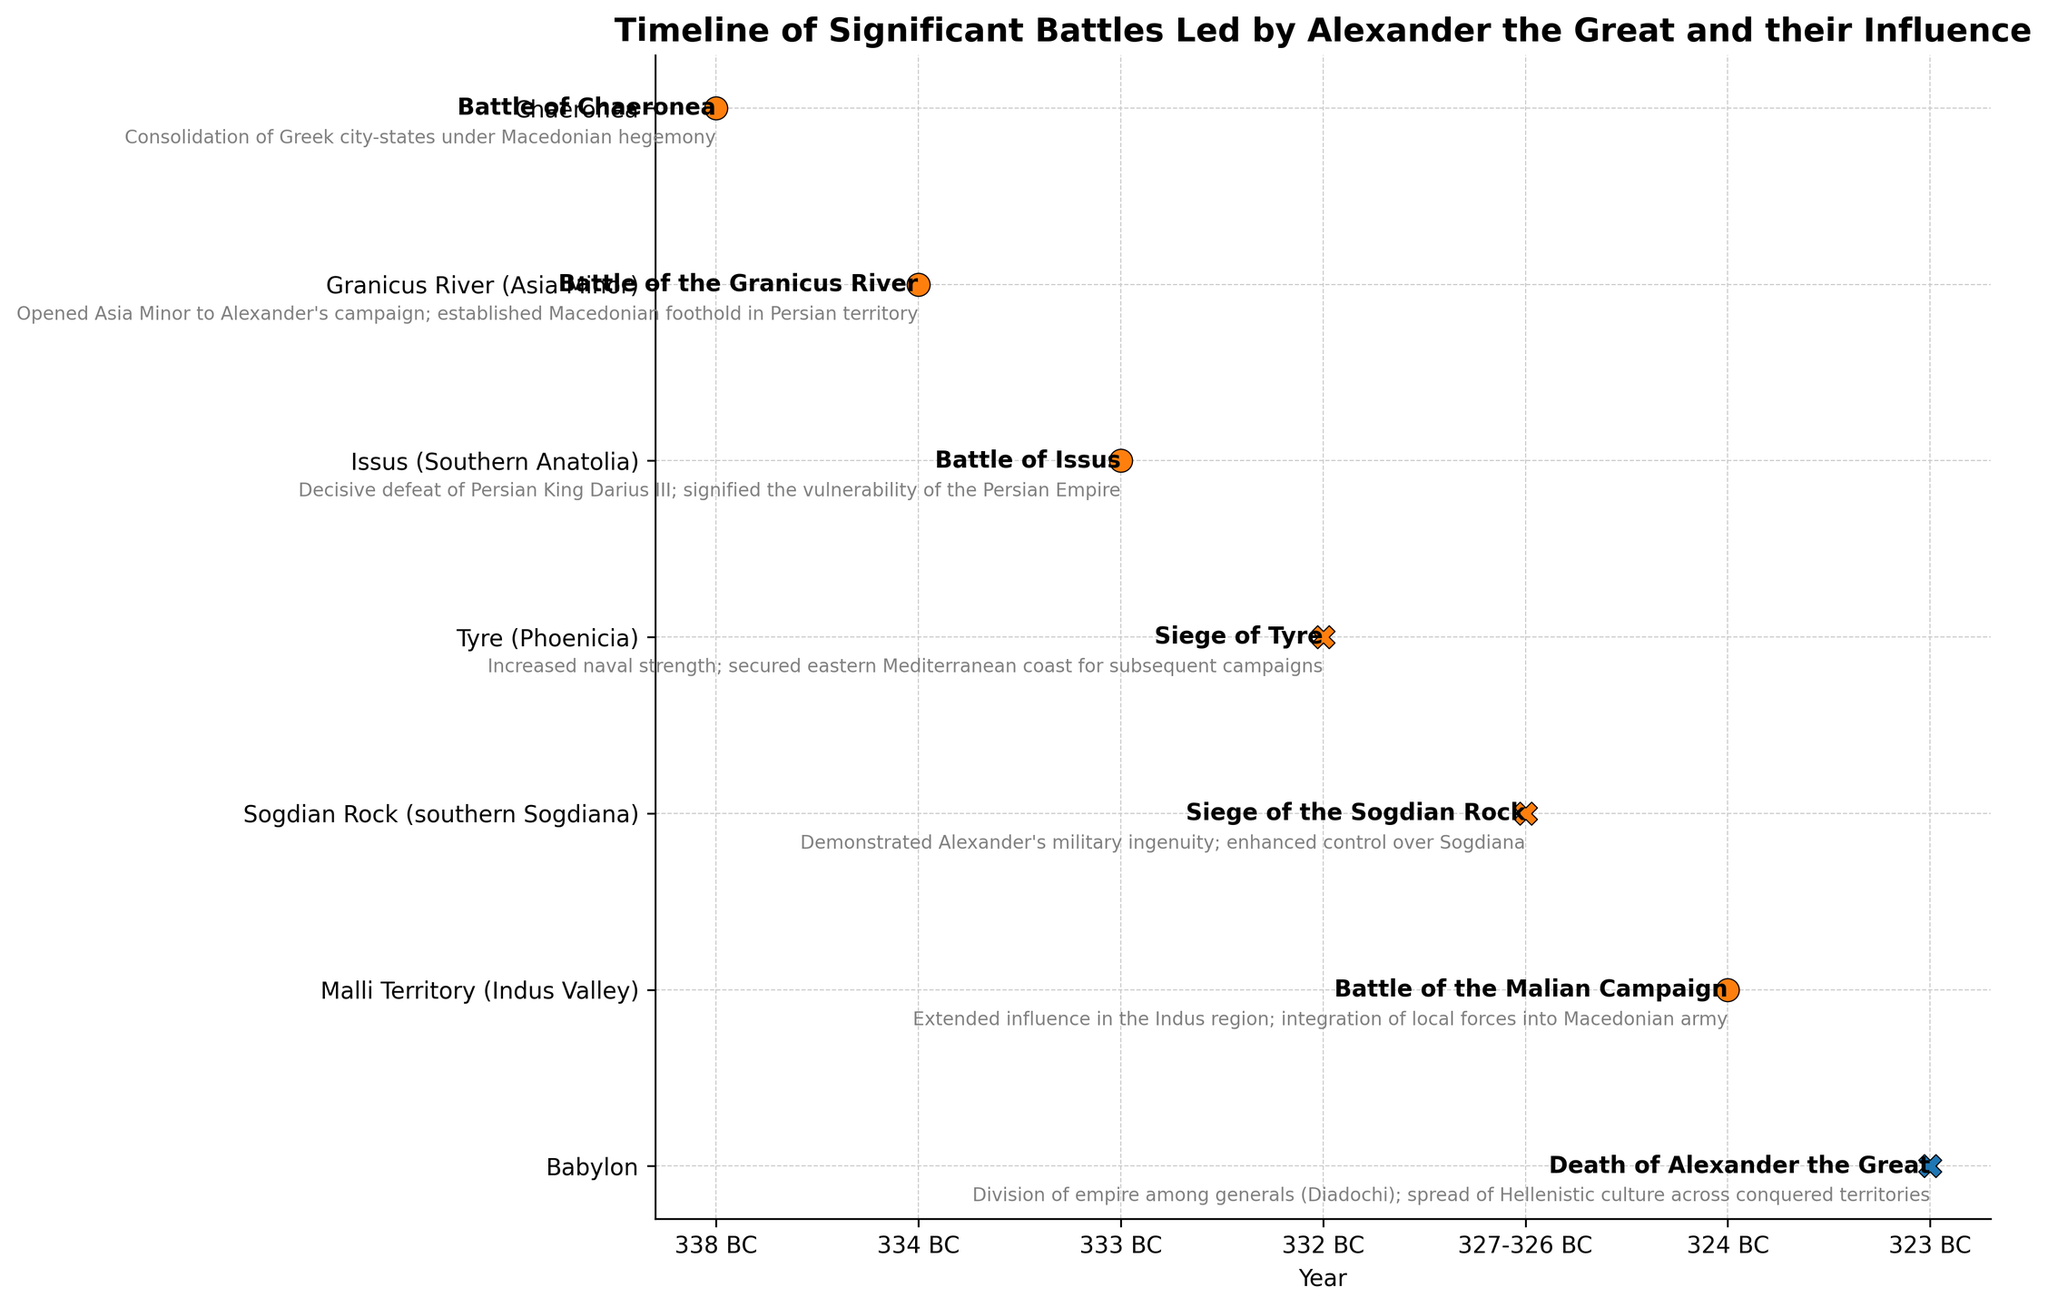When did the Battle of Chaeronea take place? Referring to the figure, locate the label "Battle of Chaeronea" and note the corresponding year marked on the timeline.
Answer: 338 BC Which battle took place in the Indus Valley, and what was its influence? Find the battle labeled in the Indus Valley on the y-axis (Malli Territory) and read the provided outcome and influence description.
Answer: Battle of the Malian Campaign; Extended influence in the Indus region; integration of local forces into Macedonian army Compare the number of battles and sieges mentioned during Alexander's campaigns. Which type is more frequent? Count the occurrences of labels with the term "Battle" and compare them to those with the term "Siege" on the figure's y-axis.
Answer: Battles are more frequent What event marked the end of Alexander's Empire, and in which year did it occur? Locate the event labeled "Death of Alexander the Great" on the timeline. The year is marked on the x-axis.
Answer: Death of Alexander the Great in 323 BC What influence did the Siege of Tyre have on subsequent campaigns? Identify the Siege of Tyre on the y-axis, then read the accompanying influence text in the figure.
Answer: Increased naval strength; secured eastern Mediterranean coast for subsequent campaigns Which battle signified the vulnerability of the Persian Empire, and what year did it take place? Locate the battle labeled "Battle of Issus" on the figure, and note the corresponding year on the x-axis. The influence text will indicate its significance.
Answer: Battle of Issus in 333 BC; signified the vulnerability of the Persian Empire What visual attribute distinguishes the "Death of Alexander the Great" event from the battles and sieges? Identify the markers used for "Death of Alexander the Great" and compare with those used for battles and sieges.
Answer: "Death of Alexander the Great" is marked with an "X" while battles and sieges are marked with circles Determine the timespan of Alexander's notable battles and sieges as depicted in the figure. Note the earliest and latest years on the timeline from the plotted points of battles and sieges, subtract the earliest year from the latest year.
Answer: 338 BC (Battle of Chaeronea) to 326 BC (Siege of the Sogdian Rock); approximately 12 years 